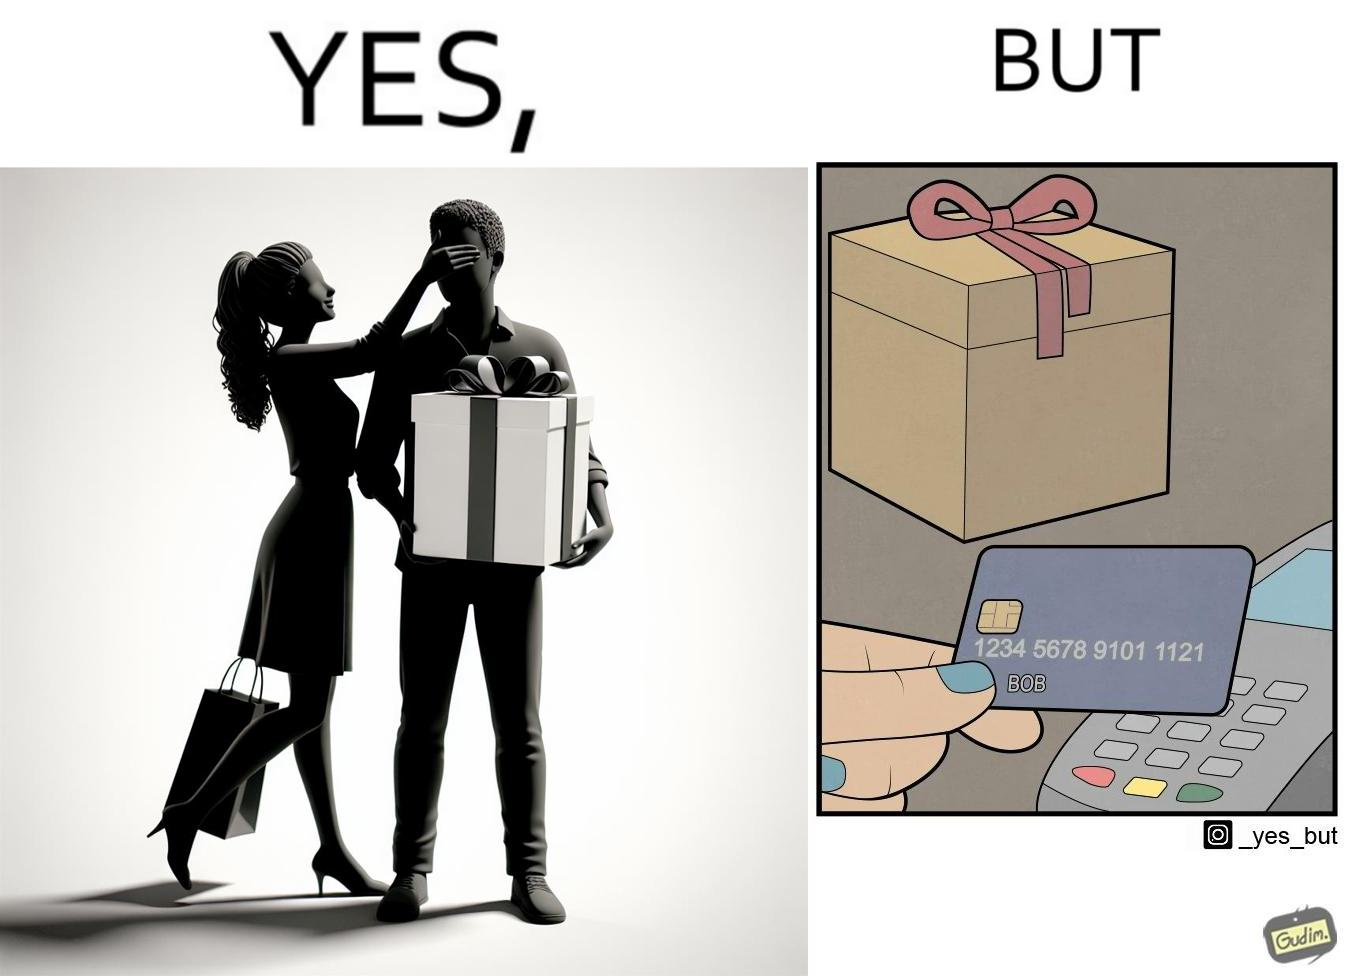Is there satirical content in this image? Yes, this image is satirical. 